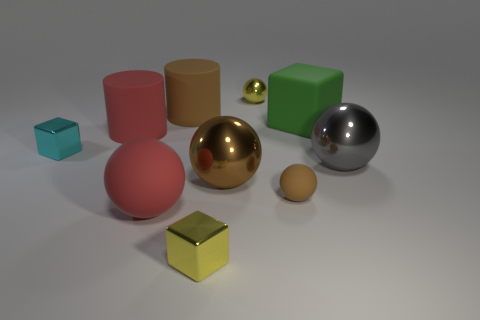Do the brown shiny object and the small yellow object behind the small rubber sphere have the same shape?
Your answer should be compact. Yes. What is the color of the small metal block on the right side of the rubber cylinder in front of the big green rubber object that is on the right side of the small yellow metal ball?
Ensure brevity in your answer.  Yellow. There is a tiny yellow metal object behind the tiny yellow metallic block; is it the same shape as the tiny brown object?
Give a very brief answer. Yes. What is the red ball made of?
Your answer should be compact. Rubber. What is the shape of the tiny yellow thing right of the tiny cube that is in front of the shiny ball in front of the large gray thing?
Your response must be concise. Sphere. How many other things are there of the same shape as the big gray thing?
Provide a succinct answer. 4. There is a small matte sphere; is it the same color as the small sphere that is behind the big gray shiny ball?
Make the answer very short. No. How many small yellow metal objects are there?
Offer a terse response. 2. How many things are tiny cyan metal blocks or small brown rubber objects?
Your answer should be compact. 2. What is the size of the metallic sphere that is the same color as the small rubber ball?
Give a very brief answer. Large. 